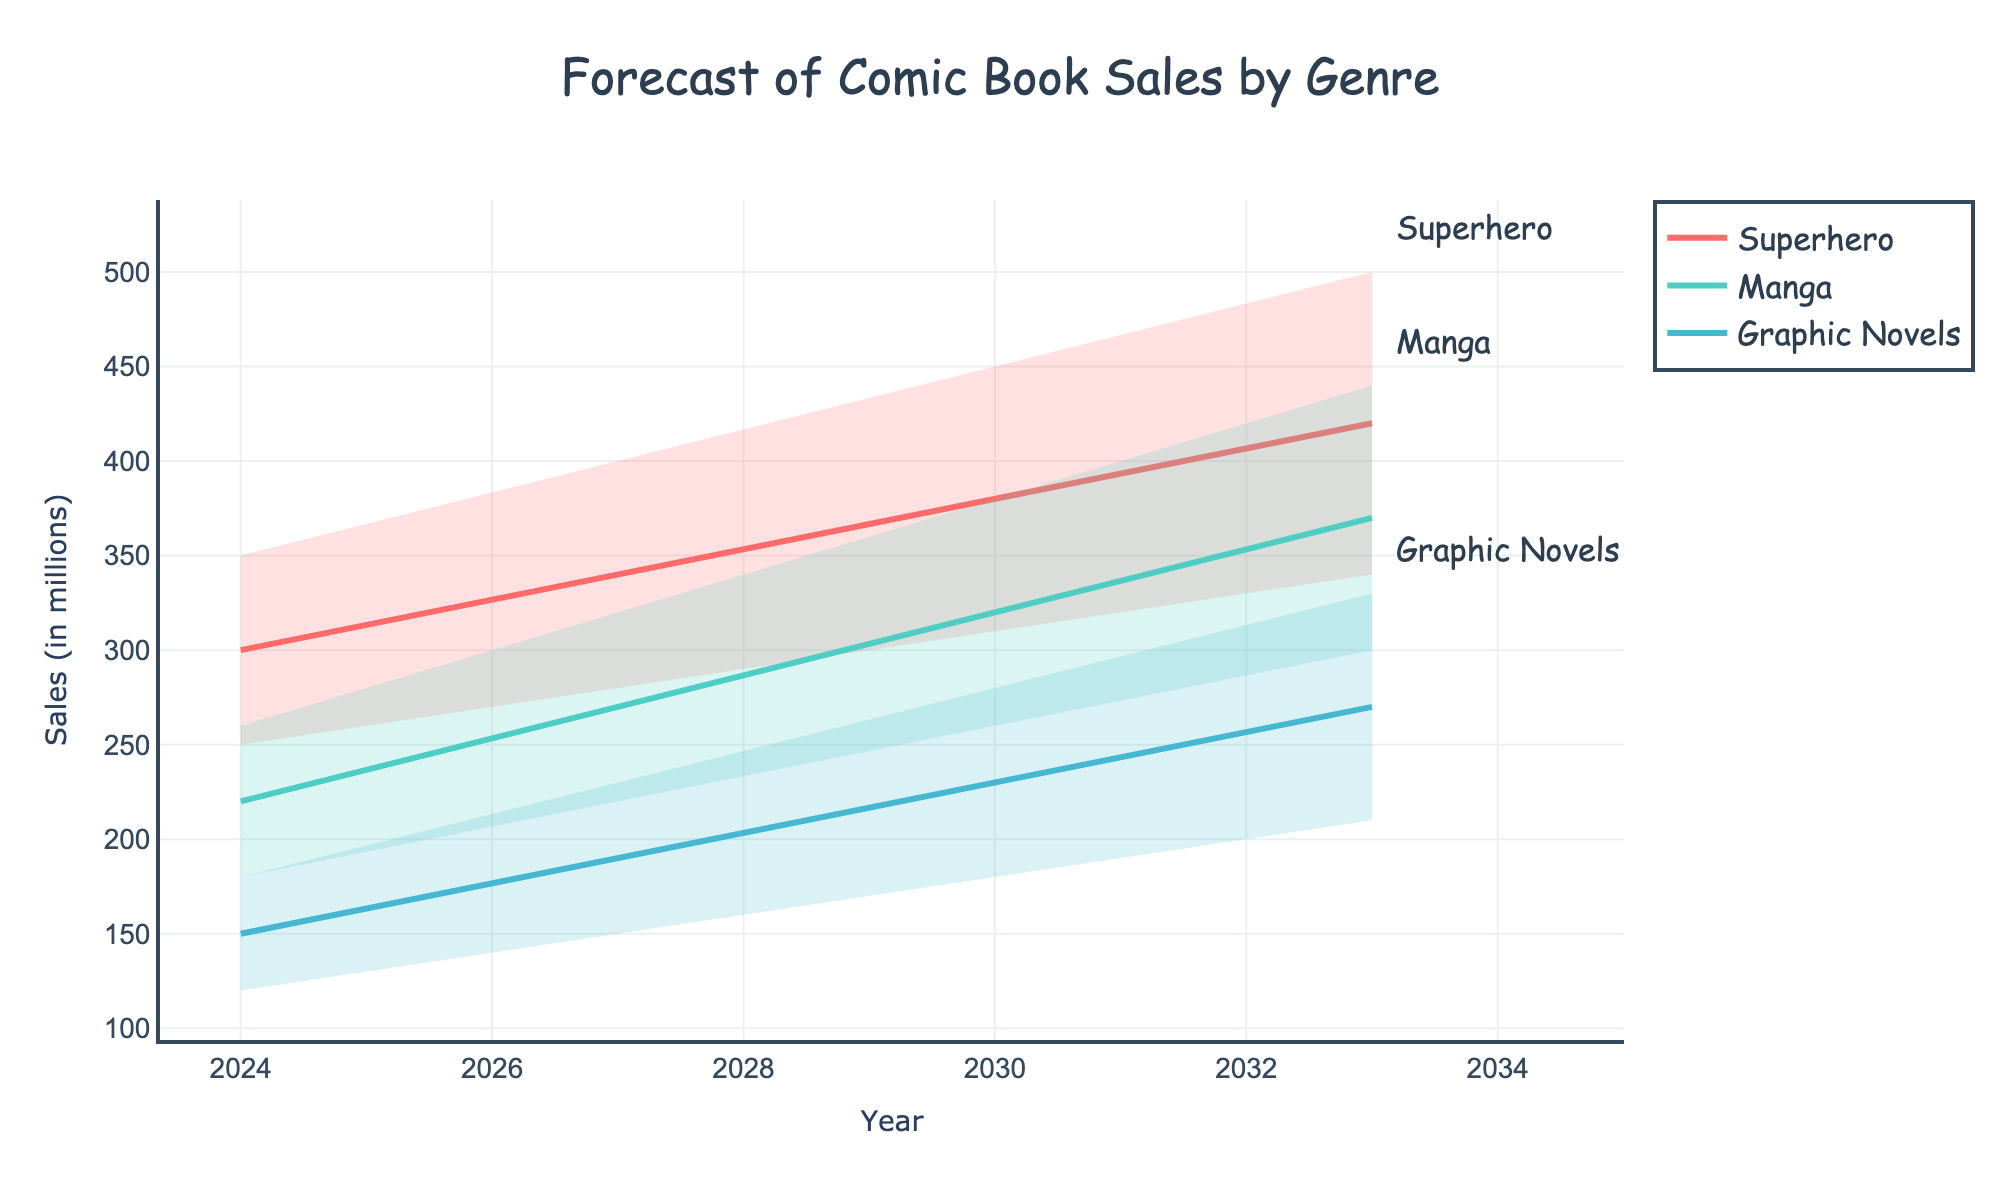How many genres are being forecasted in the figure? There are three unique genres being forecasted in the graph: superhero, manga, and graphic novels.
Answer: Three What is the forecasted mid estimate for superhero comic book sales in 2027? The mid estimate value for superhero sales in 2027 can be read directly from the figure, shown at 340 million.
Answer: 340 million By how much is the high estimate for manga sales expected to increase from 2024 to 2033? The high estimate for manga sales in 2024 is 260 million, and in 2033 it is 440 million. The increase is 440 - 260 = 180 million.
Answer: 180 million What is the average of the mid estimates for graphic novels in 2024, 2027, and 2030? The mid estimates for graphic novels are 150 (2024), 190 (2027), and 230 (2030). The average is (150 + 190 + 230) / 3 = 190 million.
Answer: 190 million Which genre is forecasted to have the highest mid estimate in 2030? Looking at the mid estimates for 2030, superhero (380 million), manga (320 million), and graphic novels (230 million), the highest is superhero.
Answer: Superhero How does the low estimate for superhero sales in 2033 compare to the low estimate for manga sales in 2027? The low estimate for superhero sales in 2033 is 340 million, whereas the low estimate for manga sales in 2027 is 220 million. 340 is greater than 220.
Answer: Superhero is higher What is the difference in the high estimates of graphic novels between 2027 and 2030? The high estimate for graphic novels in 2027 is 230 million, and in 2030 it is 280 million. The difference is 280 - 230 = 50 million.
Answer: 50 million Are the high estimates for superhero sales consistently increasing from 2024 to 2033? Observing the high estimates for superhero sales: 350 (2024), 400 (2027), 450 (2030), and 500 (2033), we see a consistent increase at each step.
Answer: Yes What is the trend for manga's mid estimates from 2024 to 2033? The mid estimates for manga from 2024 to 2033 are 220, 270, 320, and 370 million respectively, showing an increasing trend.
Answer: Increasing By comparing the genres, which one shows the greatest growth in the mid estimate from 2024 to 2033? The mid estimates for each genre's growth are calculated. Superhero: 420 - 300 = 120, Manga: 370 - 220 = 150, Graphic Novels: 270 - 150 = 120. Manga shows the greatest growth.
Answer: Manga 